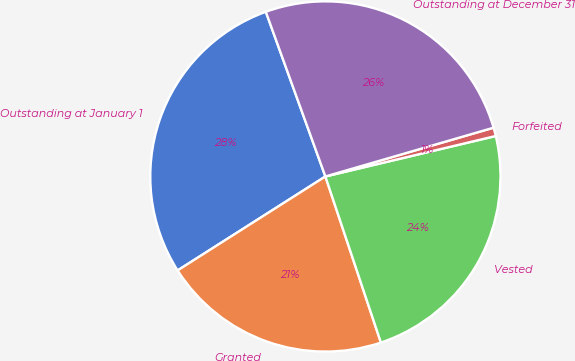<chart> <loc_0><loc_0><loc_500><loc_500><pie_chart><fcel>Outstanding at January 1<fcel>Granted<fcel>Vested<fcel>Forfeited<fcel>Outstanding at December 31<nl><fcel>28.49%<fcel>21.12%<fcel>23.58%<fcel>0.78%<fcel>26.03%<nl></chart> 